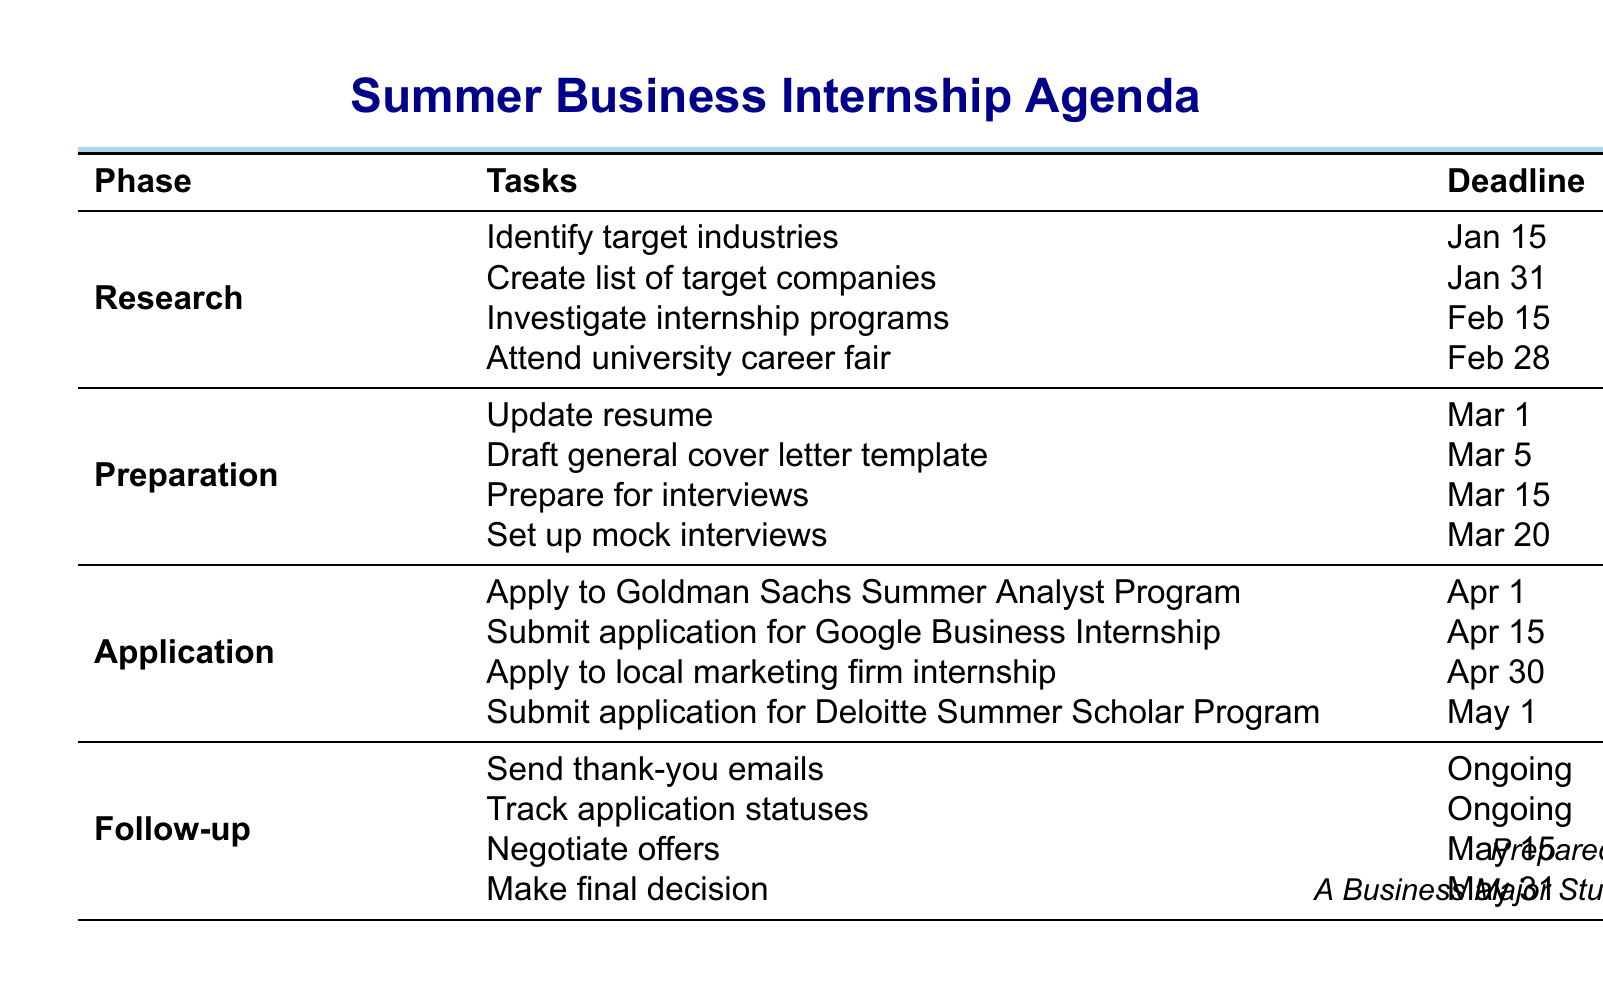What is the deadline for identifying target industries? The document lists the deadline for identifying target industries as January 15.
Answer: January 15 How many companies should be listed for target companies? The document states to compile a list of 20-30 companies for internships.
Answer: 20-30 What task is scheduled for March 1? The agenda indicates that updating the resume is the task scheduled for March 1.
Answer: Update resume When is the deadline to apply for the Goldman Sachs Summer Analyst Program? The document specifies that the application deadline for this program is April 1.
Answer: April 1 What is an ongoing task listed in the follow-up phase? The document mentions sending thank-you emails as an ongoing task.
Answer: Send thank-you emails Which company has an application deadline of May 1? The document specifies that the Deloitte Summer Scholar Program has a deadline of May 1.
Answer: Deloitte Summer Scholar Program What are target industries mentioned in the research phase? The document includes finance, marketing, consulting, and tech startups as target industries.
Answer: finance, marketing, consulting, tech startups What is the task that involves practicing interview skills? The document indicates that setting up mock interviews is the task for practicing interview skills.
Answer: Set up mock interviews 